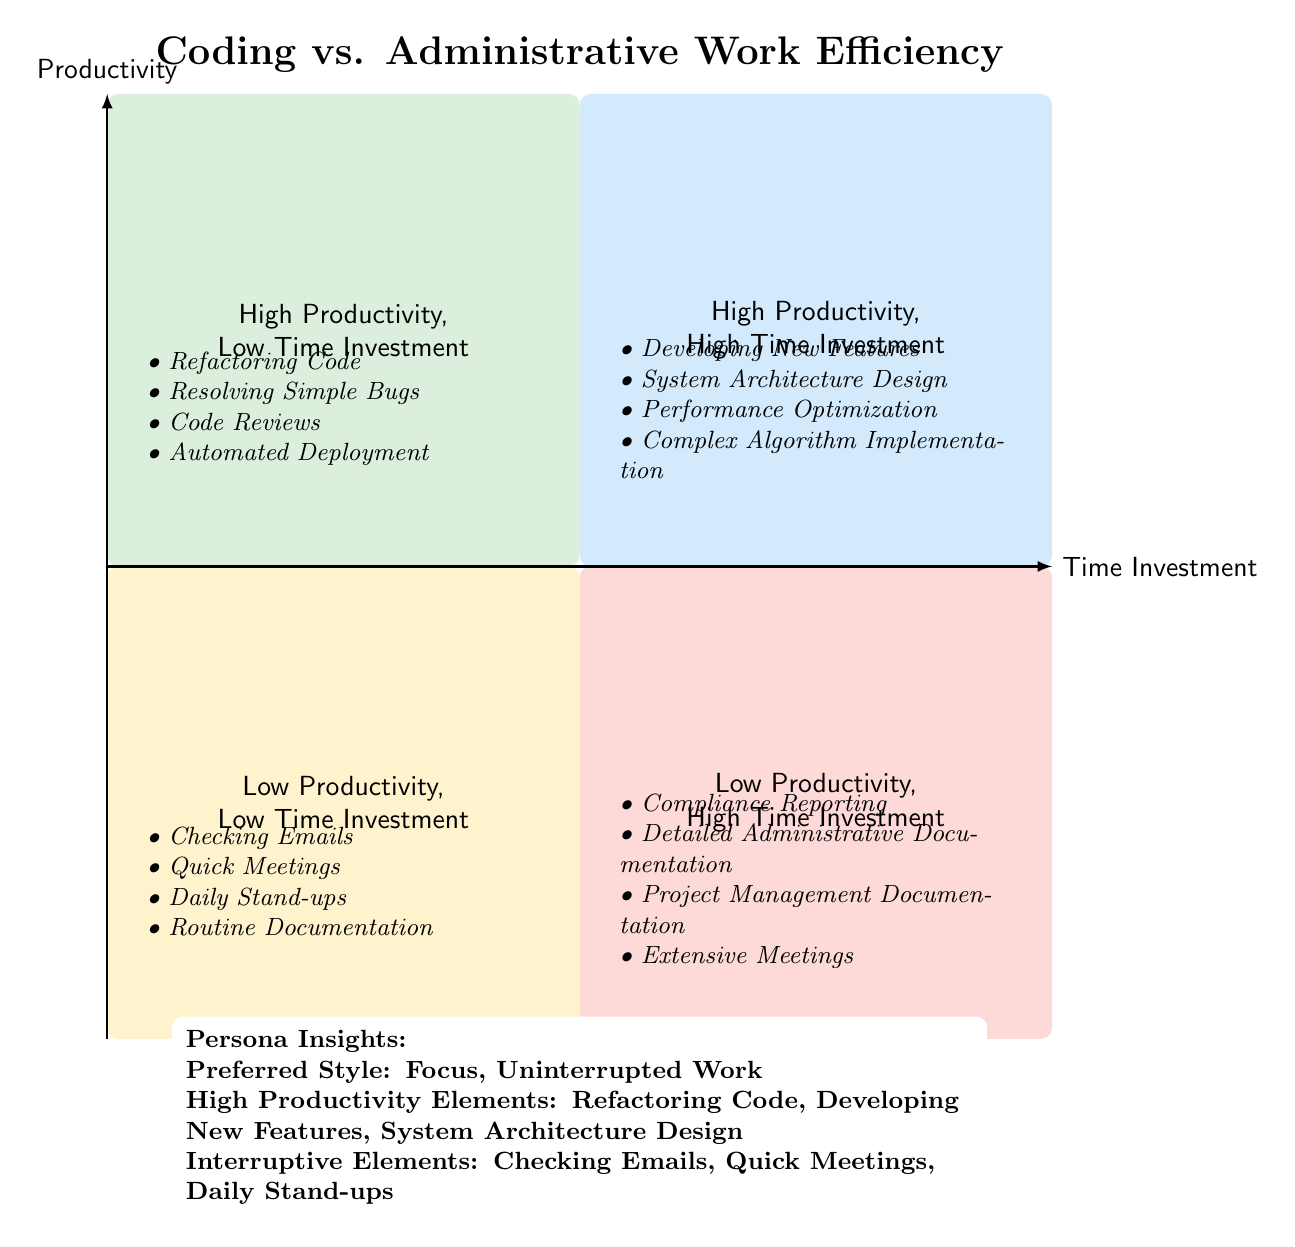What are the elements in the "High Productivity, Low Time Investment" quadrant? The elements listed in this quadrant include Refactoring Code, Resolving Simple Bugs, Code Reviews, and Automated Deployment.
Answer: Refactoring Code, Resolving Simple Bugs, Code Reviews, Automated Deployment How many elements are in the "Low Productivity, High Time Investment" quadrant? There are four elements in this quadrant: Compliance Reporting, Detailed Administrative Documentation, Project Management Documentation, and Extensive Meetings.
Answer: 4 Which task requires high time investment but has low productivity? The tasks listed in this quadrant include Compliance Reporting, Detailed Administrative Documentation, Project Management Documentation, and Extensive Meetings, all of which indicate low productivity while requiring high time investment.
Answer: Compliance Reporting What is the primary productivity style preferred in the persona insights? The preferred style mentioned in the persona insights emphasizes a need for focus and uninterrupted work, which aligns with completing coding tasks without distractions.
Answer: Focus, Uninterrupted Work Which quadrant contains the task "Developing New Features"? This task is categorized under the "High Productivity, High Time Investment" quadrant, indicating that it is both productive and time-consuming.
Answer: High Productivity, High Time Investment What is the relationship between checking emails and productivity in this chart? Checking emails is placed in the "Low Productivity, Low Time Investment" quadrant, demonstrating that while it does not demand a lot of time, it also does not contribute significantly to productive work.
Answer: Low Productivity, Low Time Investment How many quadrants represent high productivity tasks? There are two quadrants that represent high productivity tasks: High Productivity, Low Time Investment and High Productivity, High Time Investment.
Answer: 2 Which element listed under high productivity, low time investment is also a coding task? Refactoring Code is a coding task that falls under the "High Productivity, Low Time Investment" category, showcasing its efficiency and effectiveness in time management.
Answer: Refactoring Code What type of tasks typically have low productivity and low time investment? Tasks such as Checking Emails, Quick Meetings, Daily Stand-ups, and Routine Documentation characterize this category, suggesting they consume little time but are not productive.
Answer: Checking Emails 